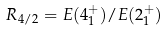<formula> <loc_0><loc_0><loc_500><loc_500>R _ { 4 / 2 } = E ( 4 _ { 1 } ^ { + } ) / E ( 2 _ { 1 } ^ { + } )</formula> 